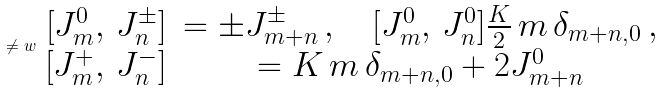<formula> <loc_0><loc_0><loc_500><loc_500>\ne w \begin{array} { r c l } { [ } J ^ { 0 } _ { m } , \, J ^ { \pm } _ { n } ] & = \pm J ^ { \pm } _ { m + n } \, , \quad [ J ^ { 0 } _ { m } , \, J ^ { 0 } _ { n } ] \frac { K } { 2 } \, m \, \delta _ { m + n , 0 } \, , \\ { [ } J ^ { + } _ { m } , \, J ^ { - } _ { n } ] & = K \, m \, \delta _ { m + n , 0 } + 2 J ^ { 0 } _ { m + n } \end{array}</formula> 